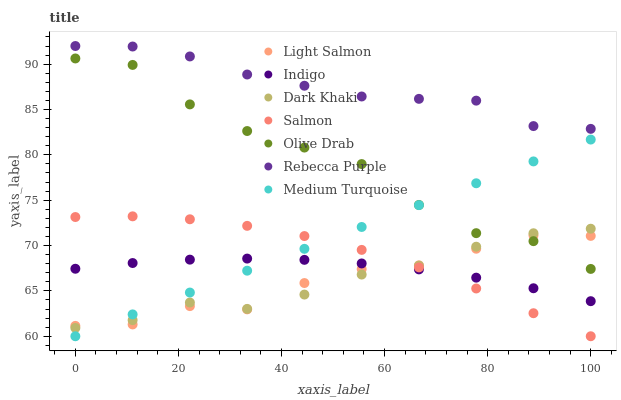Does Dark Khaki have the minimum area under the curve?
Answer yes or no. Yes. Does Rebecca Purple have the maximum area under the curve?
Answer yes or no. Yes. Does Indigo have the minimum area under the curve?
Answer yes or no. No. Does Indigo have the maximum area under the curve?
Answer yes or no. No. Is Medium Turquoise the smoothest?
Answer yes or no. Yes. Is Olive Drab the roughest?
Answer yes or no. Yes. Is Indigo the smoothest?
Answer yes or no. No. Is Indigo the roughest?
Answer yes or no. No. Does Salmon have the lowest value?
Answer yes or no. Yes. Does Indigo have the lowest value?
Answer yes or no. No. Does Rebecca Purple have the highest value?
Answer yes or no. Yes. Does Salmon have the highest value?
Answer yes or no. No. Is Salmon less than Rebecca Purple?
Answer yes or no. Yes. Is Rebecca Purple greater than Medium Turquoise?
Answer yes or no. Yes. Does Olive Drab intersect Dark Khaki?
Answer yes or no. Yes. Is Olive Drab less than Dark Khaki?
Answer yes or no. No. Is Olive Drab greater than Dark Khaki?
Answer yes or no. No. Does Salmon intersect Rebecca Purple?
Answer yes or no. No. 